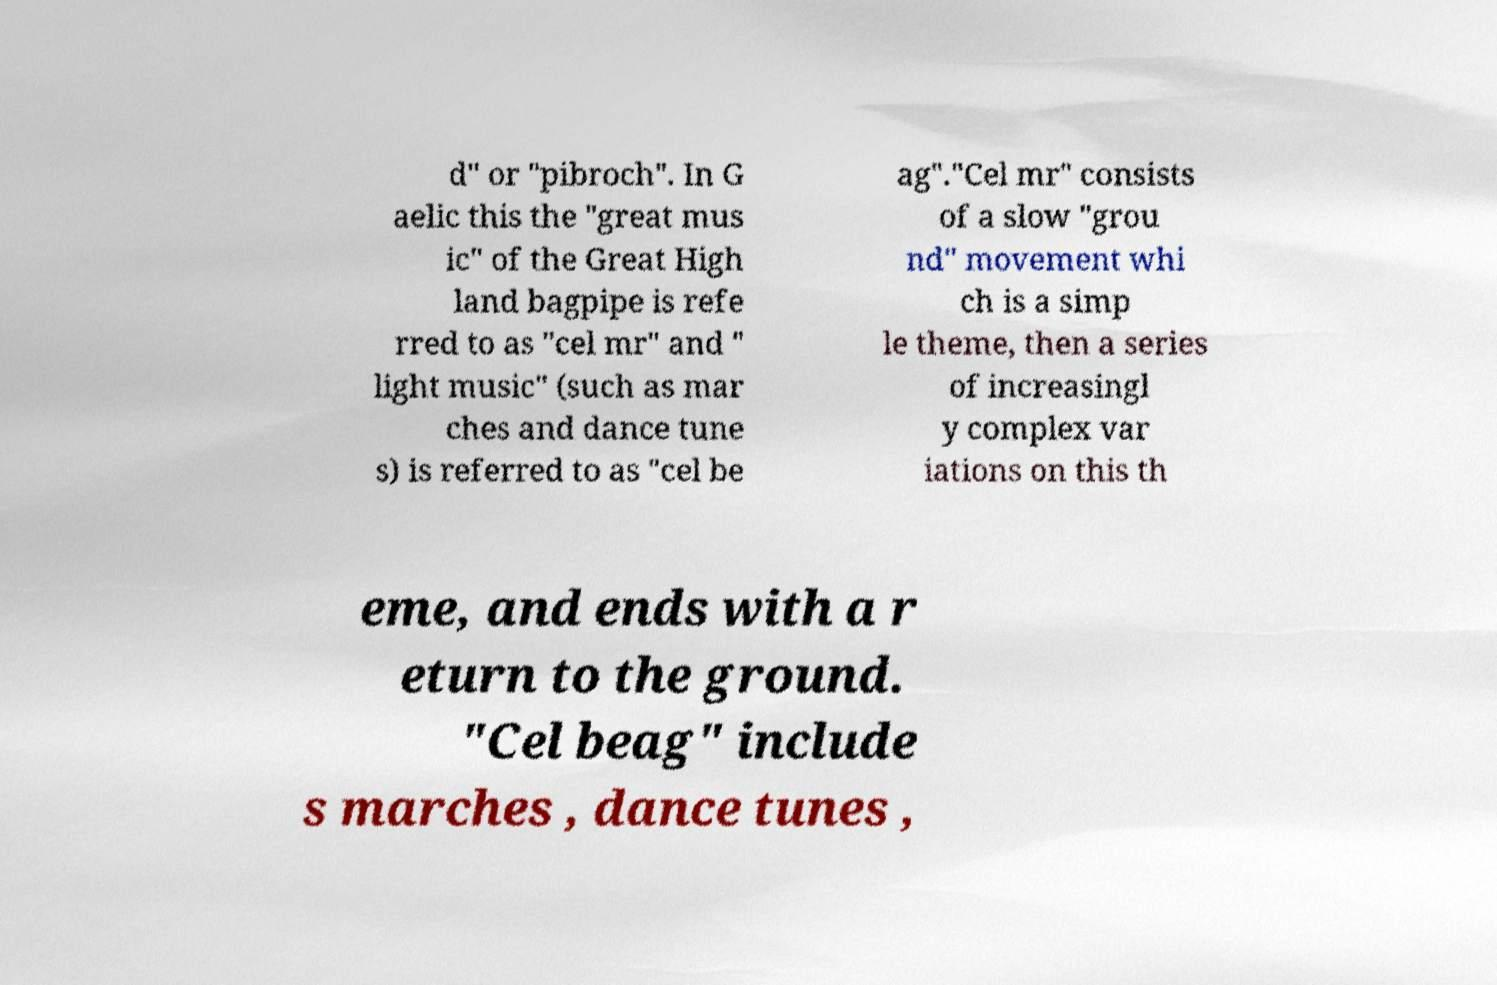What messages or text are displayed in this image? I need them in a readable, typed format. d" or "pibroch". In G aelic this the "great mus ic" of the Great High land bagpipe is refe rred to as "cel mr" and " light music" (such as mar ches and dance tune s) is referred to as "cel be ag"."Cel mr" consists of a slow "grou nd" movement whi ch is a simp le theme, then a series of increasingl y complex var iations on this th eme, and ends with a r eturn to the ground. "Cel beag" include s marches , dance tunes , 